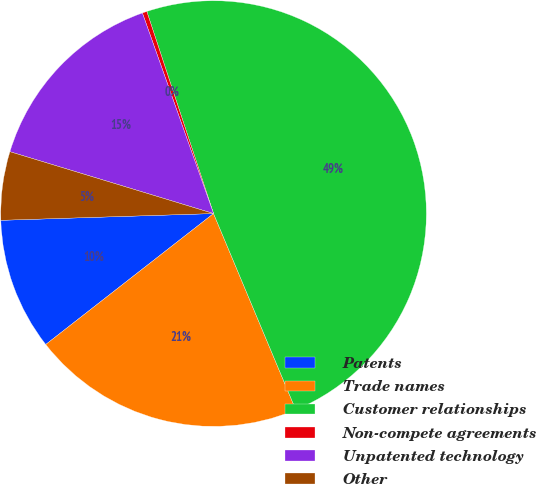<chart> <loc_0><loc_0><loc_500><loc_500><pie_chart><fcel>Patents<fcel>Trade names<fcel>Customer relationships<fcel>Non-compete agreements<fcel>Unpatented technology<fcel>Other<nl><fcel>10.04%<fcel>20.77%<fcel>48.76%<fcel>0.35%<fcel>14.88%<fcel>5.2%<nl></chart> 